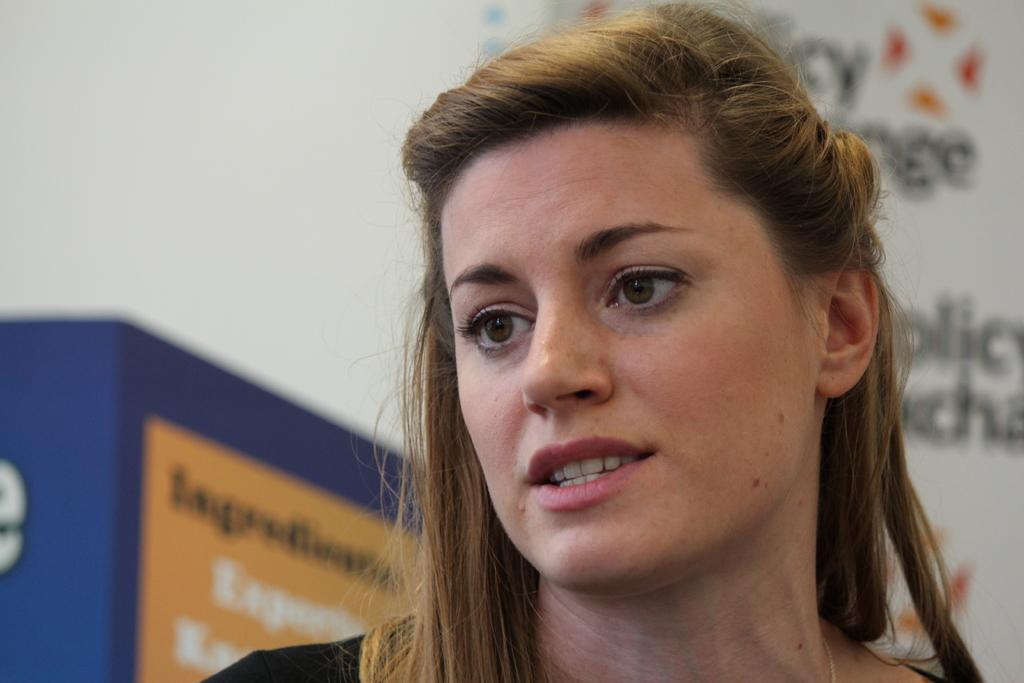Could you give a brief overview of what you see in this image? On the right side, there is a woman speaking. And the background is blurred. 